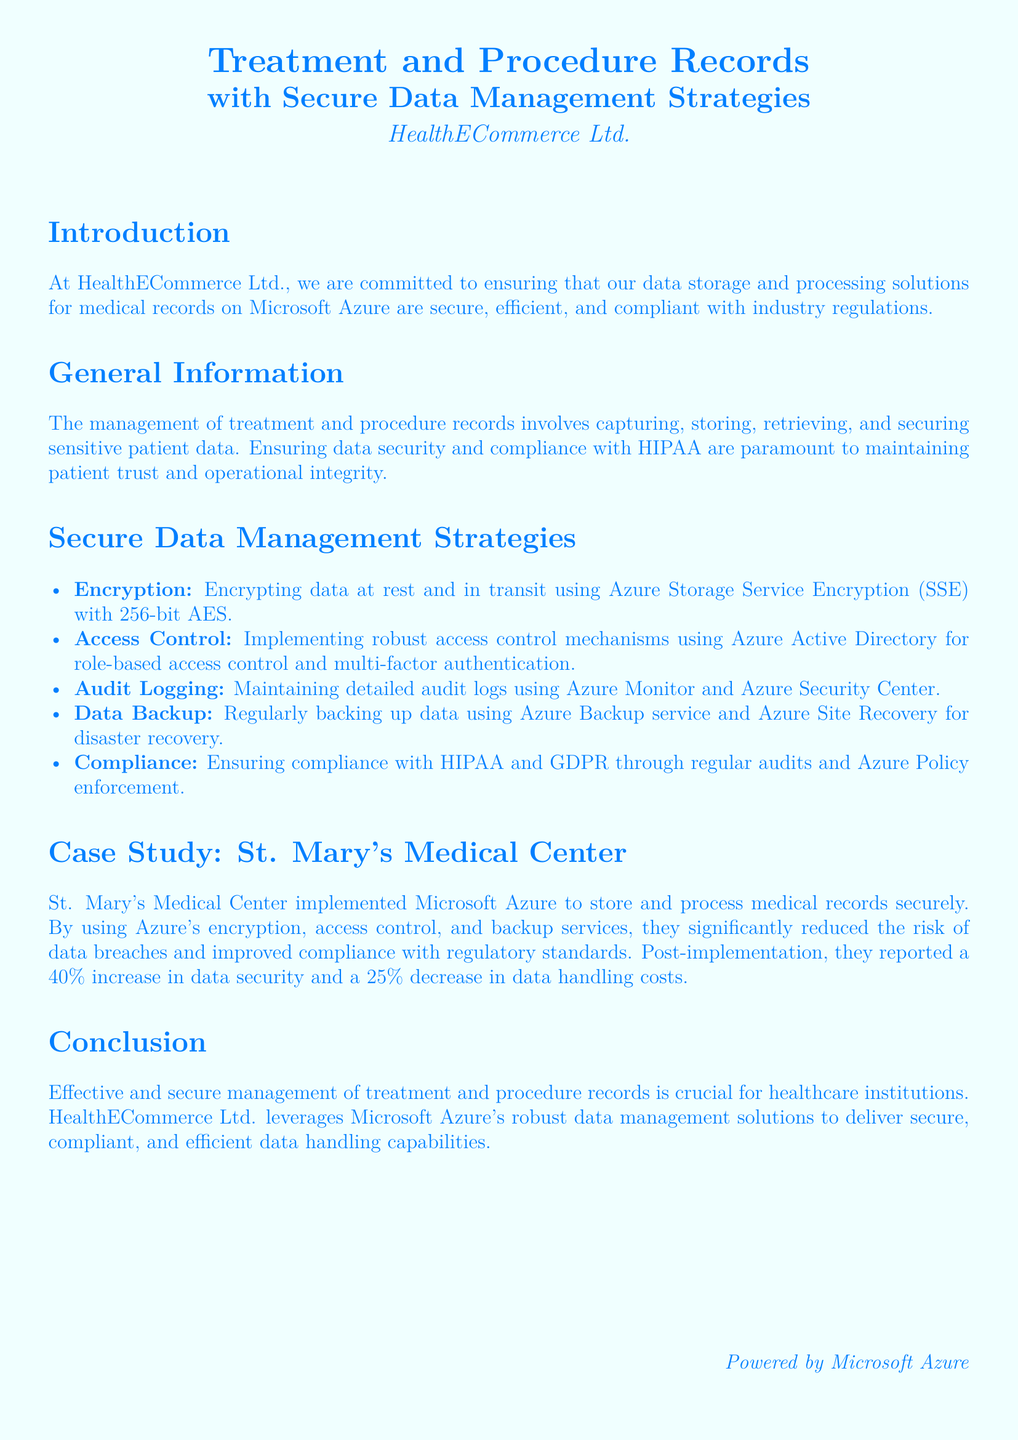What is the name of the company? The document mentions HealthECommerce Ltd. as the company that manages treatment and procedure records.
Answer: HealthECommerce Ltd What encryption standard is used for data? The document specifies that 256-bit AES is used for encrypting data at rest and in transit.
Answer: 256-bit AES What percentage increase in data security did St. Mary's Medical Center report? The case study indicates that St. Mary's Medical Center reported a 40% increase in data security after implementation.
Answer: 40% What compliance regulations are mentioned? The document refers to HIPAA and GDPR as the compliance regulations being adhered to.
Answer: HIPAA and GDPR What is the main purpose of the document? The document is aimed at explaining secure data management strategies for medical records on Microsoft Azure.
Answer: Secure data management strategies How often is data backed up according to the document? The document states that data backups are performed regularly using Azure Backup service.
Answer: Regularly What type of logging is maintained for security? The document mentions maintaining detailed audit logs as part of the security strategy.
Answer: Audit logging What was the percentage decrease in data handling costs reported? The case study indicates that there was a 25% decrease in data handling costs post-implementation.
Answer: 25% 